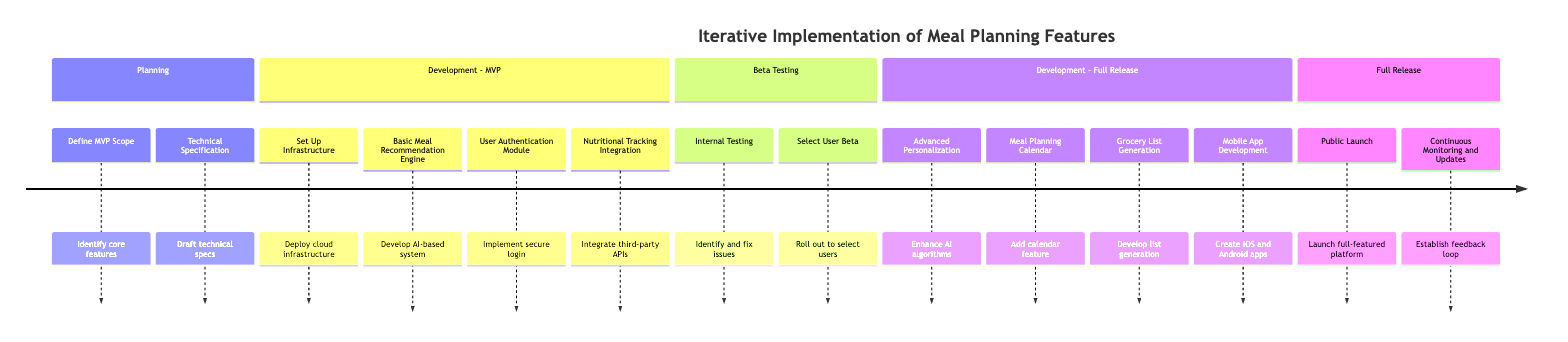What is the first phase of the timeline? The timeline starts with the "Planning" phase, which is the first section from the top.
Answer: Planning How many activities are listed under the "Beta Testing" phase? The "Beta Testing" phase contains two activities: "Internal Testing" and "Select User Beta," making a total of two activities.
Answer: 2 What feature is developed to enhance user engagement on mobile platforms? The diagram specifies "Mobile App Development" as the activity aimed at enhancing user engagement for mobile platforms.
Answer: Mobile App Development Which activity is focused on detecting and fixing critical issues? "Internal Testing" is the activity designed to identify and address critical bugs and performance issues.
Answer: Internal Testing What does the "Continuous Monitoring and Updates" activity involve? This activity is about establishing a feedback loop for ongoing monitoring and regular updates based on user feedback, as noted in the timeline.
Answer: Feedback loop Which phase includes the "Grocery List Generation" activity? The "Development - Full Release" phase contains the "Grocery List Generation" activity, indicating its focus on that stage of development.
Answer: Development - Full Release How many phases are included in the timeline? The timeline consists of five distinct phases: Planning, Development - MVP, Beta Testing, Development - Full Release, and Full Release, totaling five phases.
Answer: 5 What is the core function identified in the MVP scope? The "Define MVP Scope" activity identifies core features such as meal suggestions, user accounts, and basic nutritional tracking as its central function.
Answer: Meal suggestions In what phase do users first test the meal planning platform? Users first test the meal planning platform during the "Beta Testing" phase, where it is rolled out to a select group for feedback.
Answer: Beta Testing What is the purpose of the "Meal Planning Calendar" feature? The "Meal Planning Calendar" allows users to plan meals over weeks and months, as described in the "Development - Full Release" phase.
Answer: Plan meals over weeks and months 